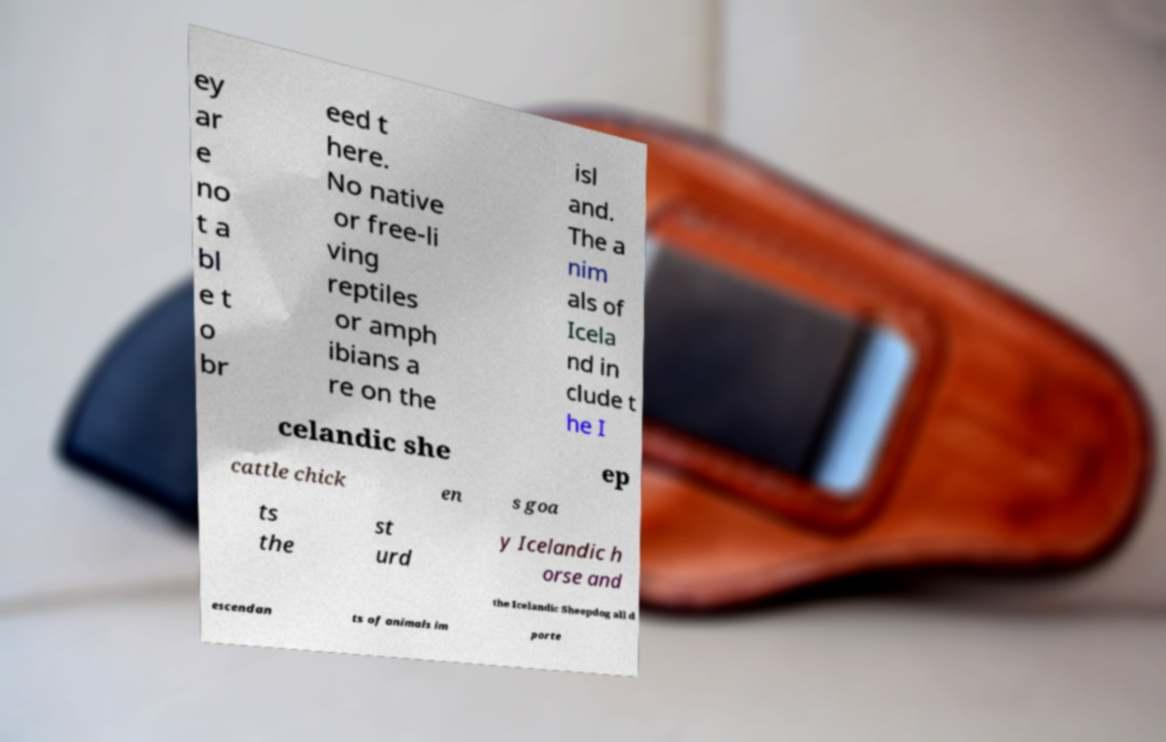For documentation purposes, I need the text within this image transcribed. Could you provide that? ey ar e no t a bl e t o br eed t here. No native or free-li ving reptiles or amph ibians a re on the isl and. The a nim als of Icela nd in clude t he I celandic she ep cattle chick en s goa ts the st urd y Icelandic h orse and the Icelandic Sheepdog all d escendan ts of animals im porte 